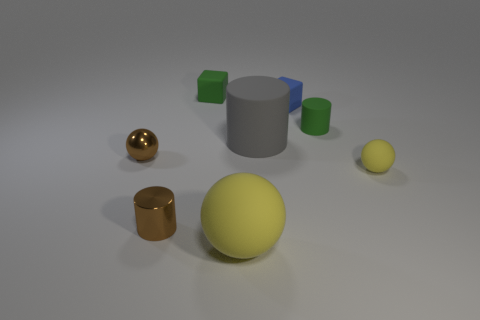Add 1 cylinders. How many objects exist? 9 Subtract all small yellow balls. How many balls are left? 2 Subtract all gray cylinders. How many cylinders are left? 2 Subtract all cylinders. How many objects are left? 5 Subtract all gray balls. Subtract all gray blocks. How many balls are left? 3 Subtract all green blocks. How many cyan cylinders are left? 0 Subtract all small purple objects. Subtract all large gray objects. How many objects are left? 7 Add 7 yellow objects. How many yellow objects are left? 9 Add 4 small green cylinders. How many small green cylinders exist? 5 Subtract 0 cyan spheres. How many objects are left? 8 